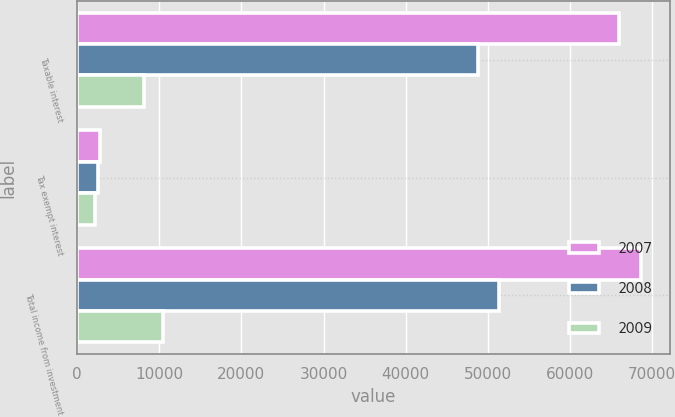Convert chart. <chart><loc_0><loc_0><loc_500><loc_500><stacked_bar_chart><ecel><fcel>Taxable interest<fcel>Tax exempt interest<fcel>Total income from investment<nl><fcel>2007<fcel>65959<fcel>2735<fcel>68694<nl><fcel>2008<fcel>48787<fcel>2489<fcel>51345<nl><fcel>2009<fcel>8125<fcel>2197<fcel>10502<nl></chart> 